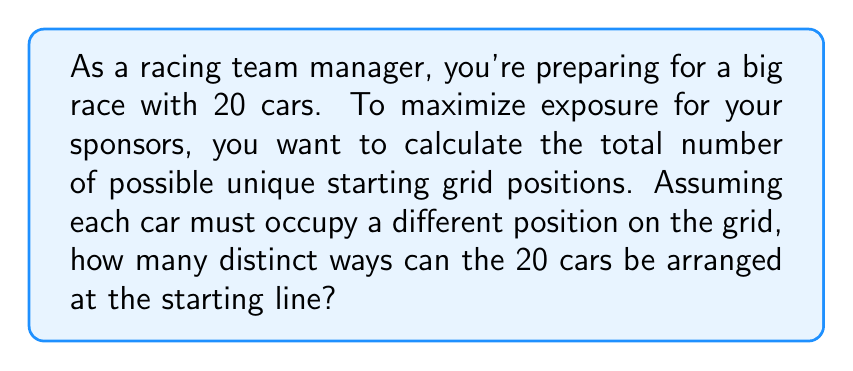Solve this math problem. Let's approach this step-by-step:

1) This problem is a classic example of a permutation. We need to arrange 20 distinct cars in 20 distinct positions.

2) In permutation problems, the order matters (the first position is different from the second, third, etc.), and each car can only be used once.

3) The formula for permutations of n distinct objects is:

   $$P(n) = n!$$

   Where $n!$ represents the factorial of n.

4) In this case, $n = 20$, so we need to calculate $20!$

5) Let's expand this:

   $$20! = 20 \times 19 \times 18 \times 17 \times ... \times 3 \times 2 \times 1$$

6) Calculating this out:

   $$20! = 2,432,902,008,176,640,000$$

This means there are 2,432,902,008,176,640,000 unique ways to arrange 20 cars on the starting grid.

This vast number of possibilities highlights the importance of grid position in racing, as each arrangement could potentially lead to different race dynamics and sponsor visibility.
Answer: $20! = 2,432,902,008,176,640,000$ 